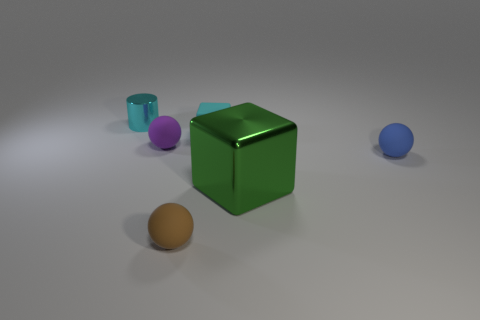Add 3 cyan metal objects. How many objects exist? 9 Subtract all blue matte spheres. How many spheres are left? 2 Subtract all brown balls. How many balls are left? 2 Add 3 big shiny objects. How many big shiny objects are left? 4 Add 4 gray metallic balls. How many gray metallic balls exist? 4 Subtract 0 gray balls. How many objects are left? 6 Subtract all cylinders. How many objects are left? 5 Subtract 2 cubes. How many cubes are left? 0 Subtract all brown balls. Subtract all purple blocks. How many balls are left? 2 Subtract all gray cubes. How many brown spheres are left? 1 